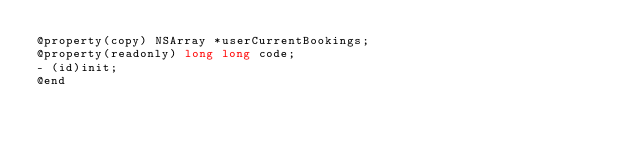<code> <loc_0><loc_0><loc_500><loc_500><_C_>@property(copy) NSArray *userCurrentBookings;
@property(readonly) long long code;
- (id)init;
@end

</code> 